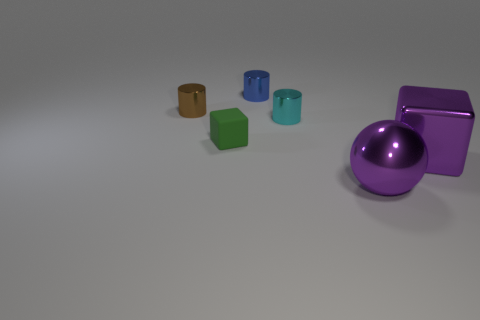Add 1 shiny blocks. How many objects exist? 7 Subtract all blue cylinders. How many cylinders are left? 2 Subtract all balls. How many objects are left? 5 Subtract 0 red balls. How many objects are left? 6 Subtract all yellow spheres. Subtract all blue blocks. How many spheres are left? 1 Subtract all small yellow metallic objects. Subtract all tiny green rubber blocks. How many objects are left? 5 Add 1 small shiny cylinders. How many small shiny cylinders are left? 4 Add 3 green cubes. How many green cubes exist? 4 